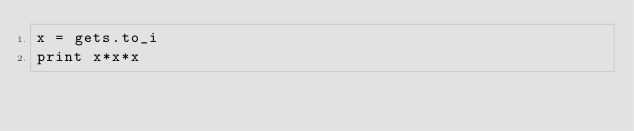Convert code to text. <code><loc_0><loc_0><loc_500><loc_500><_Ruby_>x = gets.to_i
print x*x*x</code> 